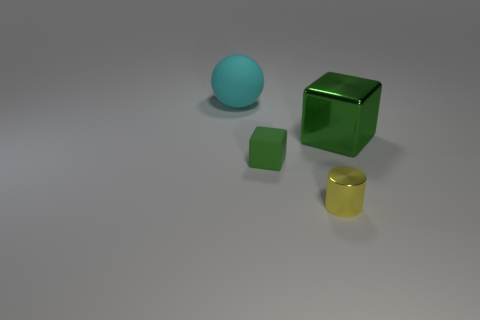Subtract all red balls. Subtract all gray cylinders. How many balls are left? 1 Add 2 purple matte cylinders. How many objects exist? 6 Subtract all cylinders. How many objects are left? 3 Add 2 yellow things. How many yellow things are left? 3 Add 4 small yellow objects. How many small yellow objects exist? 5 Subtract 0 brown cylinders. How many objects are left? 4 Subtract all cyan balls. Subtract all red metallic cylinders. How many objects are left? 3 